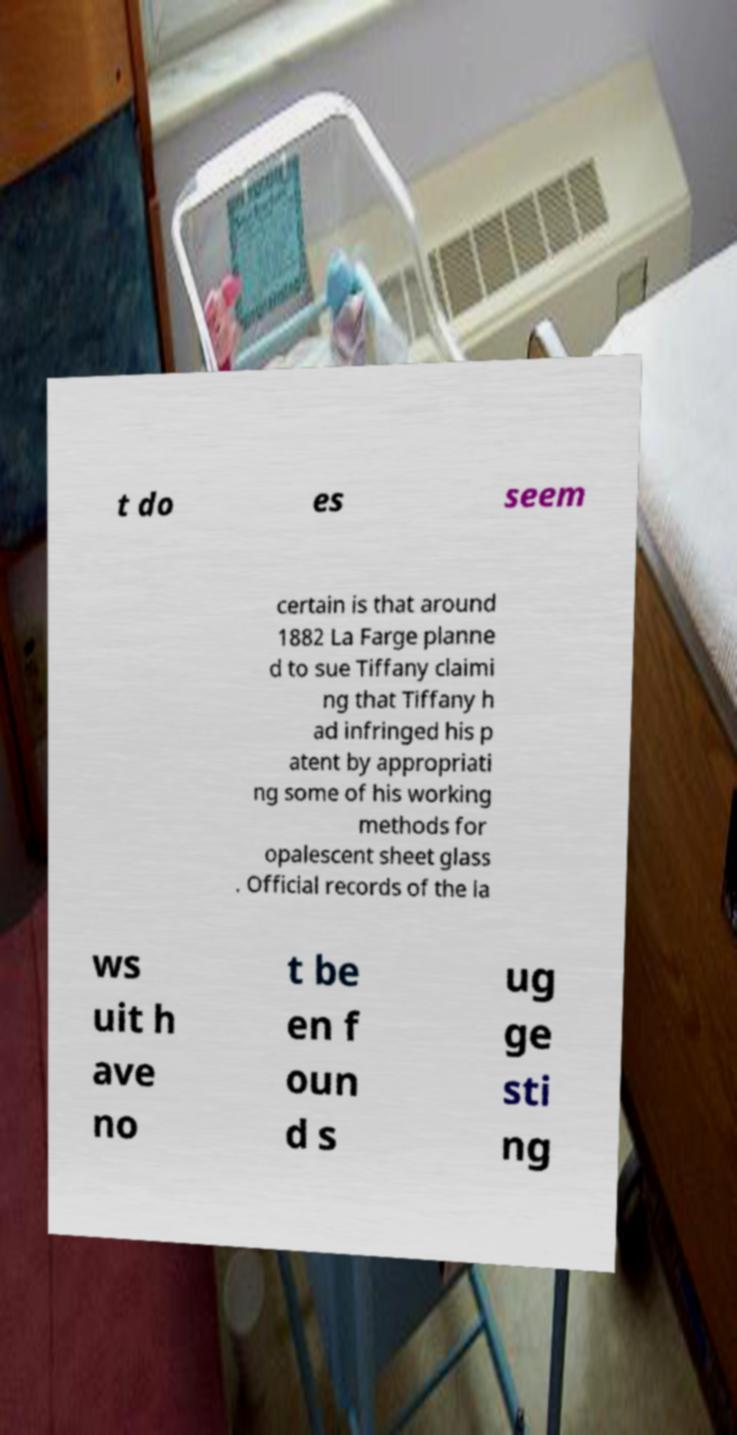I need the written content from this picture converted into text. Can you do that? t do es seem certain is that around 1882 La Farge planne d to sue Tiffany claimi ng that Tiffany h ad infringed his p atent by appropriati ng some of his working methods for opalescent sheet glass . Official records of the la ws uit h ave no t be en f oun d s ug ge sti ng 